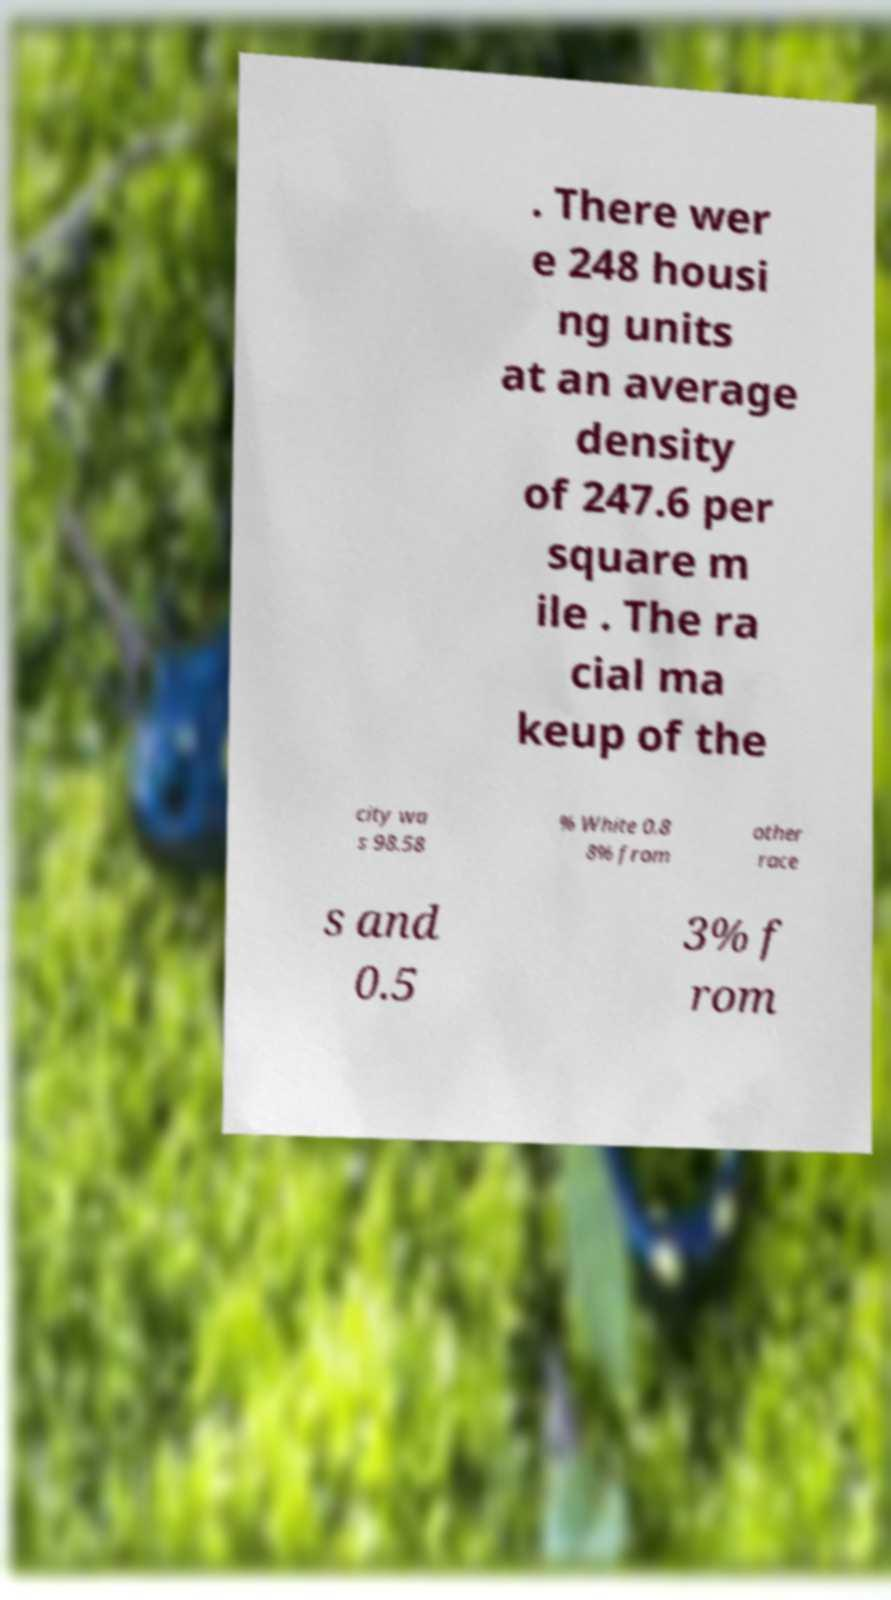Can you accurately transcribe the text from the provided image for me? . There wer e 248 housi ng units at an average density of 247.6 per square m ile . The ra cial ma keup of the city wa s 98.58 % White 0.8 8% from other race s and 0.5 3% f rom 